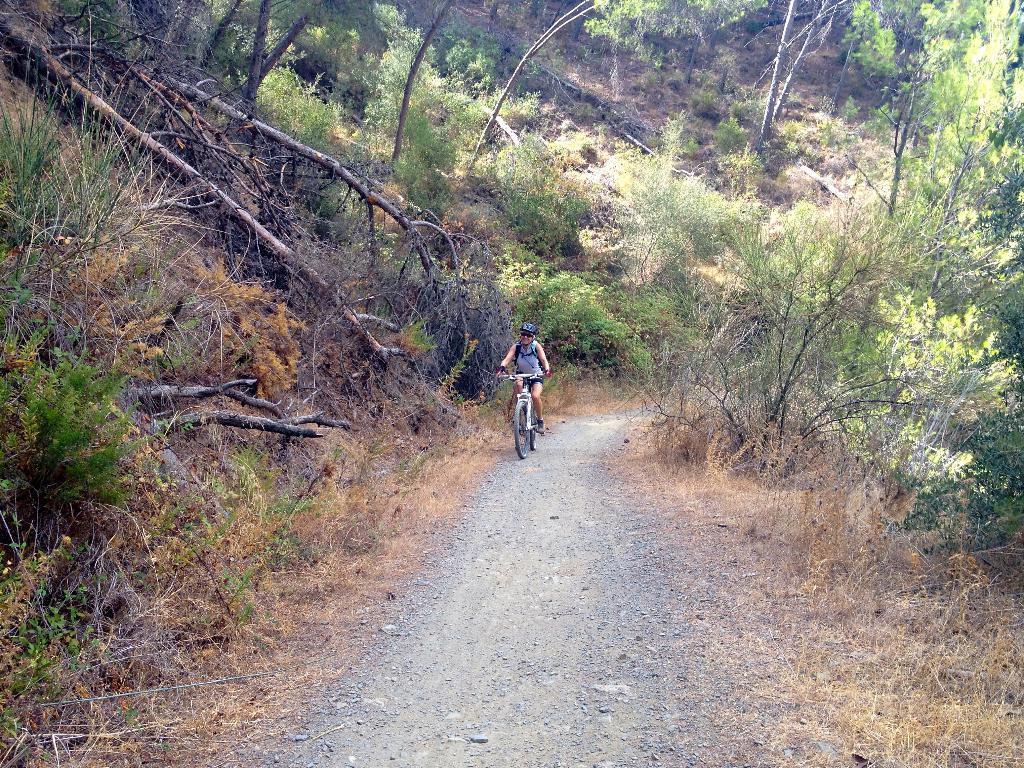How would you summarize this image in a sentence or two? In this image I can see the road, a person riding a bicycle on the road, few trees which are green, brown and black in color on both sides of the road and In the background I can see a mountain. 